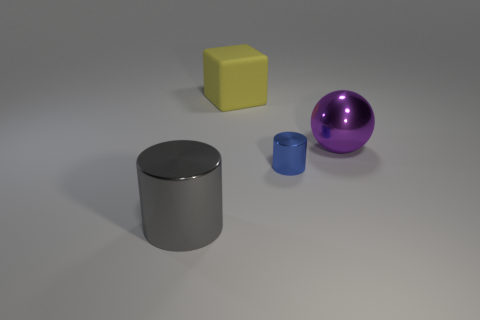Are there any other things that are the same material as the yellow object?
Provide a short and direct response. No. There is a rubber thing that is the same size as the sphere; what color is it?
Ensure brevity in your answer.  Yellow. There is a large metal thing that is to the left of the big thing that is right of the rubber object; is there a rubber cube that is in front of it?
Your response must be concise. No. There is a yellow thing that is the same size as the purple metal object; what is its shape?
Make the answer very short. Cube. What is the color of the other shiny thing that is the same shape as the small shiny object?
Offer a terse response. Gray. There is a big shiny object that is behind the big shiny cylinder; is it the same shape as the object that is behind the purple metal thing?
Provide a short and direct response. No. There is a big thing that is to the right of the large matte cube; what shape is it?
Ensure brevity in your answer.  Sphere. Are there the same number of matte objects in front of the small metallic cylinder and big gray cylinders behind the purple metallic object?
Offer a terse response. Yes. How many things are tiny yellow shiny things or big things behind the small blue metallic thing?
Offer a very short reply. 2. The thing that is both left of the purple shiny object and behind the tiny blue metallic thing has what shape?
Provide a short and direct response. Cube. 